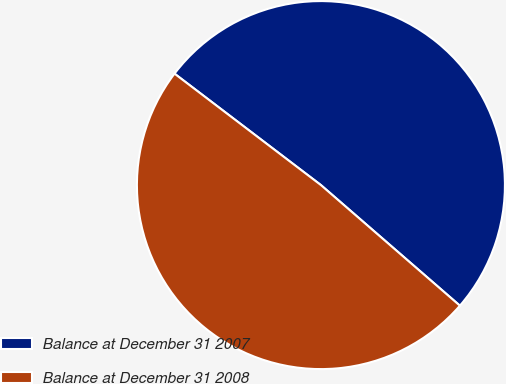<chart> <loc_0><loc_0><loc_500><loc_500><pie_chart><fcel>Balance at December 31 2007<fcel>Balance at December 31 2008<nl><fcel>51.02%<fcel>48.98%<nl></chart> 